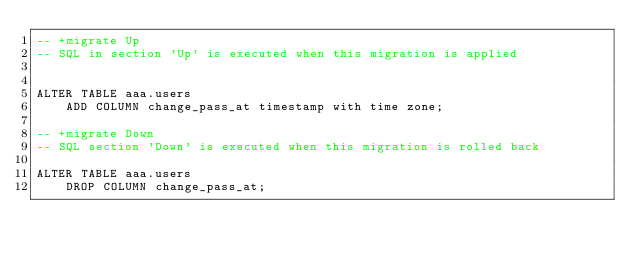<code> <loc_0><loc_0><loc_500><loc_500><_SQL_>-- +migrate Up
-- SQL in section 'Up' is executed when this migration is applied


ALTER TABLE aaa.users
    ADD COLUMN change_pass_at timestamp with time zone;

-- +migrate Down
-- SQL section 'Down' is executed when this migration is rolled back

ALTER TABLE aaa.users
    DROP COLUMN change_pass_at;
</code> 